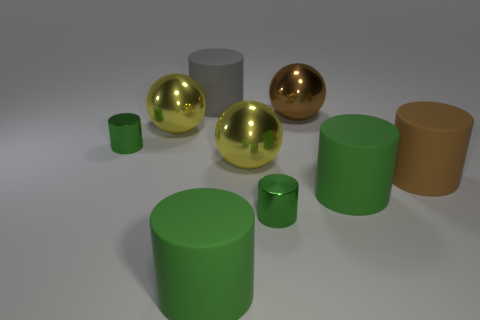Subtract all gray rubber cylinders. How many cylinders are left? 5 Add 1 big brown cylinders. How many objects exist? 10 Subtract all gray cylinders. How many cylinders are left? 5 Subtract 1 cylinders. How many cylinders are left? 5 Subtract all big purple matte cylinders. Subtract all tiny things. How many objects are left? 7 Add 2 large cylinders. How many large cylinders are left? 6 Add 2 matte cylinders. How many matte cylinders exist? 6 Subtract 0 cyan cubes. How many objects are left? 9 Subtract all cylinders. How many objects are left? 3 Subtract all cyan balls. Subtract all brown cylinders. How many balls are left? 3 